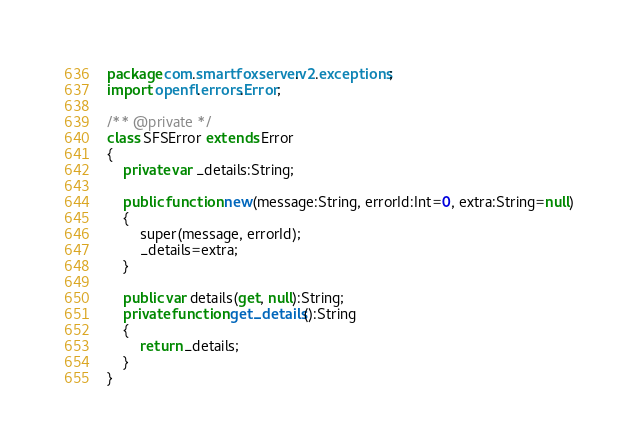<code> <loc_0><loc_0><loc_500><loc_500><_Haxe_>package com.smartfoxserver.v2.exceptions;
import openfl.errors.Error;

/** @private */
class SFSError extends Error
{
	private var _details:String;
	
	public function new(message:String, errorId:Int=0, extra:String=null)
	{
		super(message, errorId);
		_details=extra;
	}
	
	public var details(get, null):String;
 	private function get_details():String
	{
		return _details;
	}
}</code> 